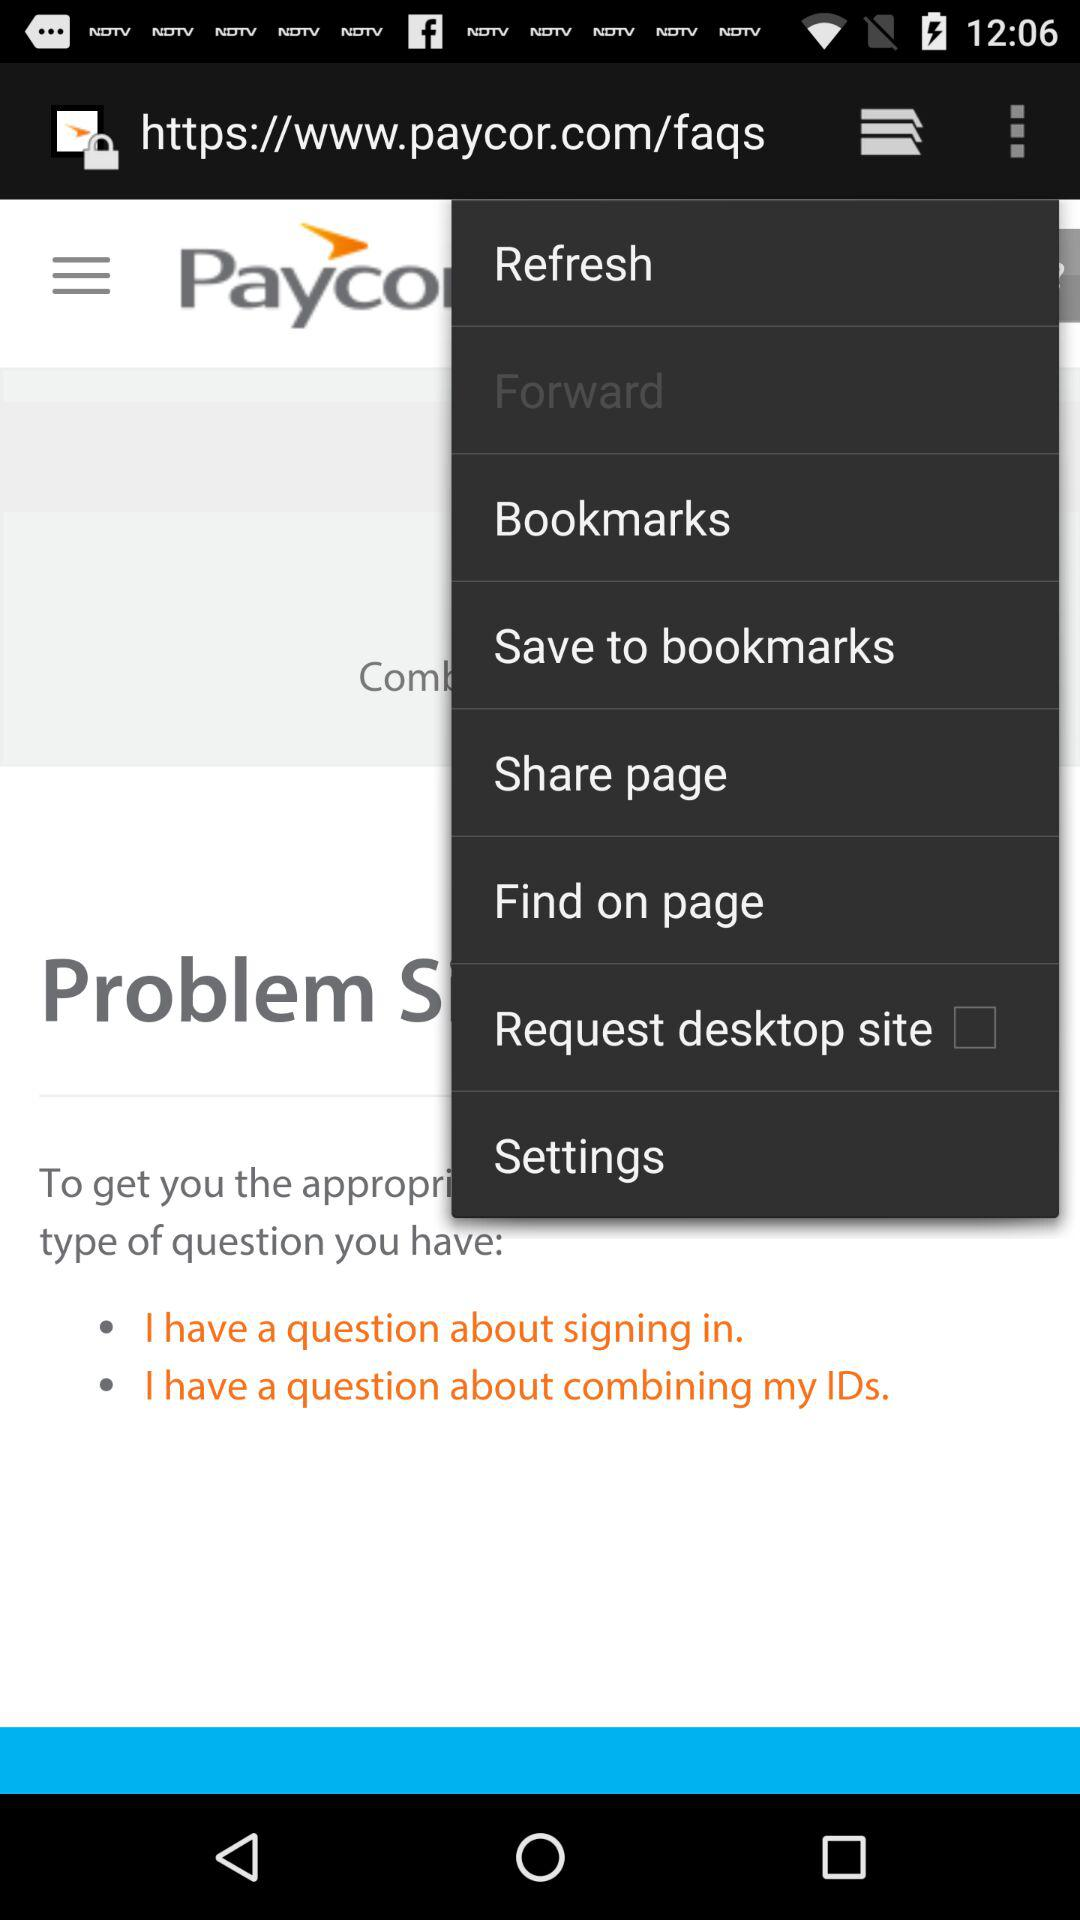When is customer support available?
When the provided information is insufficient, respond with <no answer>. <no answer> 